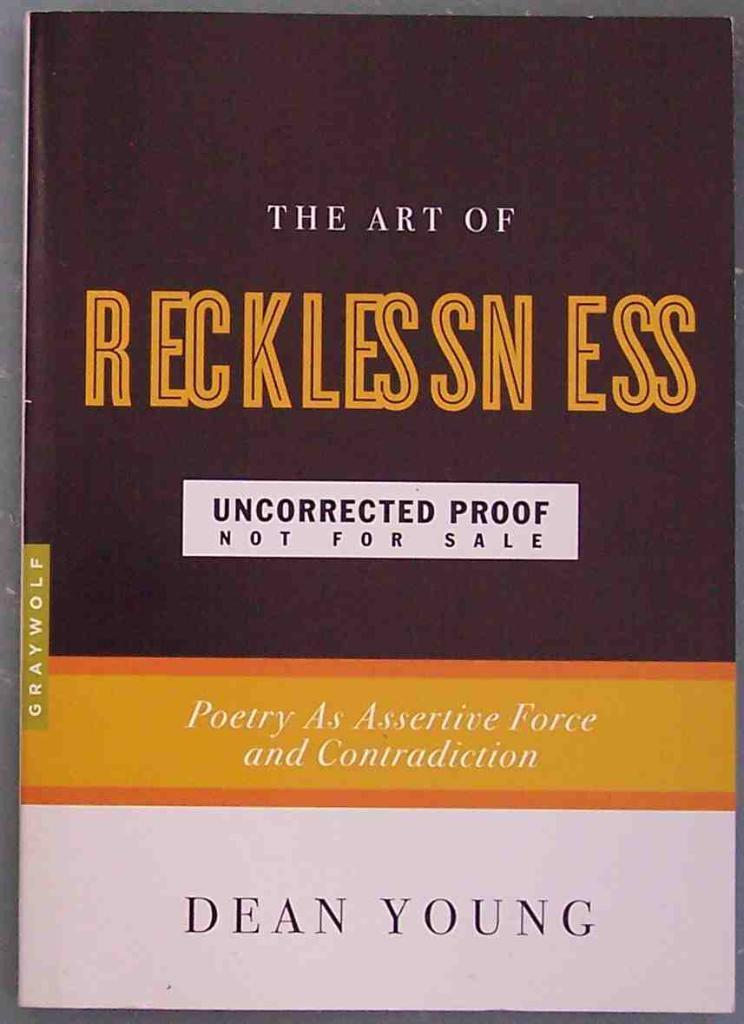<image>
Offer a succinct explanation of the picture presented. The Art of Recklessness is a book about poetry by Dean Young. 